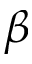<formula> <loc_0><loc_0><loc_500><loc_500>\beta</formula> 